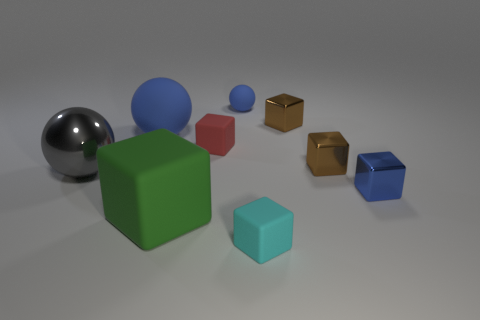There is a small thing that is the same color as the small rubber sphere; what is its shape? cube 